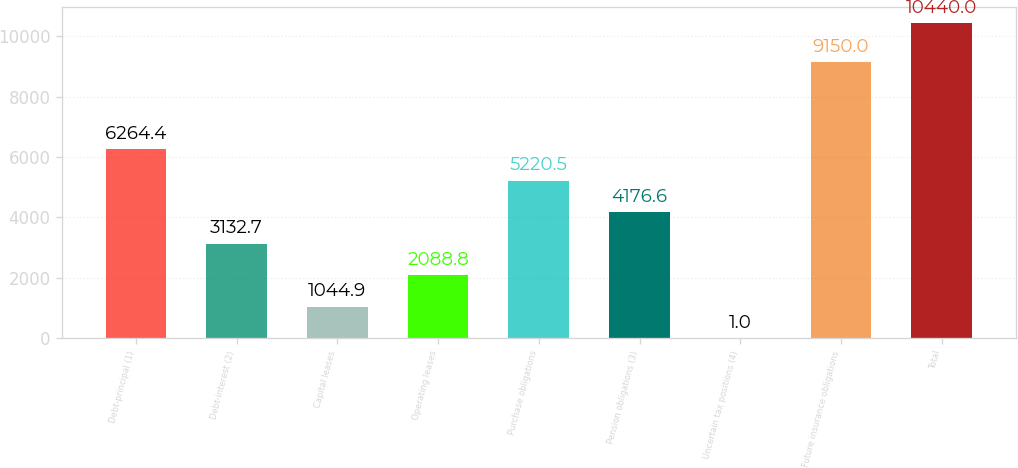Convert chart. <chart><loc_0><loc_0><loc_500><loc_500><bar_chart><fcel>Debt-principal (1)<fcel>Debt-interest (2)<fcel>Capital leases<fcel>Operating leases<fcel>Purchase obligations<fcel>Pension obligations (3)<fcel>Uncertain tax positions (4)<fcel>Future insurance obligations<fcel>Total<nl><fcel>6264.4<fcel>3132.7<fcel>1044.9<fcel>2088.8<fcel>5220.5<fcel>4176.6<fcel>1<fcel>9150<fcel>10440<nl></chart> 